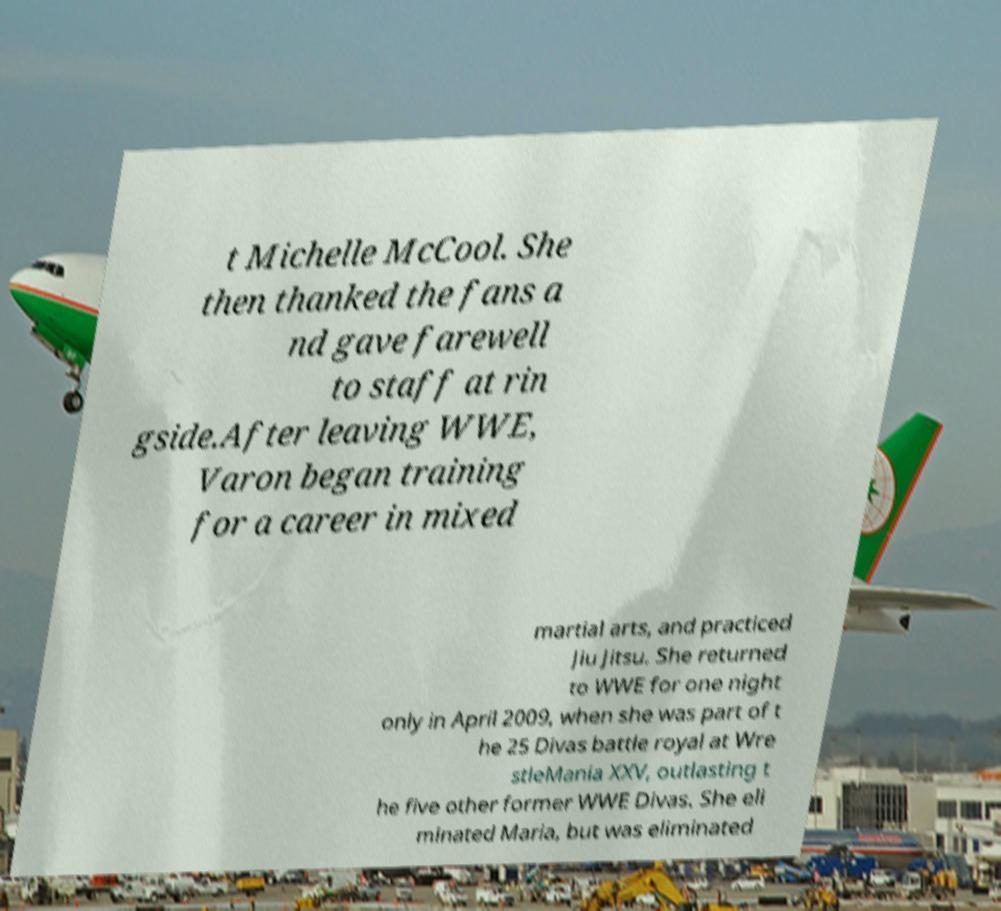Please read and relay the text visible in this image. What does it say? t Michelle McCool. She then thanked the fans a nd gave farewell to staff at rin gside.After leaving WWE, Varon began training for a career in mixed martial arts, and practiced Jiu Jitsu. She returned to WWE for one night only in April 2009, when she was part of t he 25 Divas battle royal at Wre stleMania XXV, outlasting t he five other former WWE Divas. She eli minated Maria, but was eliminated 